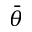<formula> <loc_0><loc_0><loc_500><loc_500>\bar { \theta }</formula> 